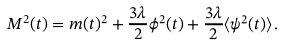<formula> <loc_0><loc_0><loc_500><loc_500>M ^ { 2 } ( t ) = m ( t ) ^ { 2 } + \frac { 3 \lambda } { 2 } \phi ^ { 2 } ( t ) + \frac { 3 \lambda } { 2 } \langle \psi ^ { 2 } ( t ) \rangle \, .</formula> 